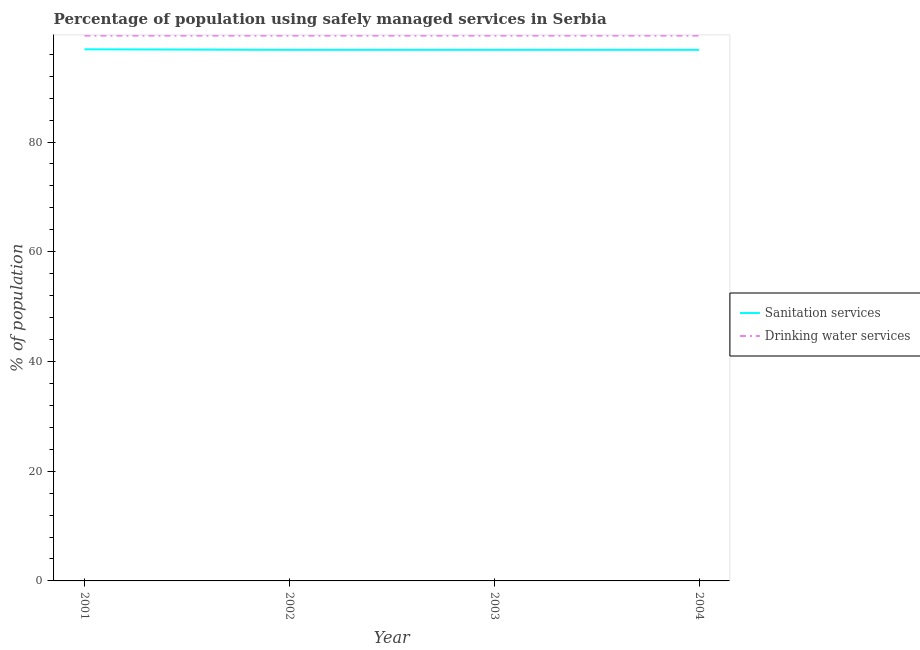How many different coloured lines are there?
Offer a very short reply. 2. Is the number of lines equal to the number of legend labels?
Give a very brief answer. Yes. What is the percentage of population who used sanitation services in 2004?
Your answer should be very brief. 96.8. Across all years, what is the maximum percentage of population who used drinking water services?
Provide a short and direct response. 99.4. Across all years, what is the minimum percentage of population who used drinking water services?
Make the answer very short. 99.4. In which year was the percentage of population who used drinking water services minimum?
Provide a succinct answer. 2001. What is the total percentage of population who used sanitation services in the graph?
Your answer should be compact. 387.3. What is the difference between the percentage of population who used sanitation services in 2003 and that in 2004?
Keep it short and to the point. 0. What is the average percentage of population who used sanitation services per year?
Keep it short and to the point. 96.83. In the year 2004, what is the difference between the percentage of population who used sanitation services and percentage of population who used drinking water services?
Your answer should be compact. -2.6. In how many years, is the percentage of population who used sanitation services greater than 84 %?
Offer a very short reply. 4. What is the ratio of the percentage of population who used drinking water services in 2001 to that in 2004?
Offer a terse response. 1. Is the percentage of population who used sanitation services in 2001 less than that in 2004?
Give a very brief answer. No. What is the difference between the highest and the second highest percentage of population who used sanitation services?
Provide a short and direct response. 0.1. What is the difference between the highest and the lowest percentage of population who used drinking water services?
Offer a very short reply. 0. In how many years, is the percentage of population who used sanitation services greater than the average percentage of population who used sanitation services taken over all years?
Offer a very short reply. 1. Is the sum of the percentage of population who used sanitation services in 2001 and 2003 greater than the maximum percentage of population who used drinking water services across all years?
Your answer should be very brief. Yes. Is the percentage of population who used drinking water services strictly less than the percentage of population who used sanitation services over the years?
Your answer should be very brief. No. How many lines are there?
Your response must be concise. 2. Does the graph contain any zero values?
Provide a succinct answer. No. Where does the legend appear in the graph?
Your answer should be compact. Center right. How many legend labels are there?
Provide a short and direct response. 2. What is the title of the graph?
Make the answer very short. Percentage of population using safely managed services in Serbia. Does "Forest land" appear as one of the legend labels in the graph?
Give a very brief answer. No. What is the label or title of the Y-axis?
Your response must be concise. % of population. What is the % of population in Sanitation services in 2001?
Provide a succinct answer. 96.9. What is the % of population of Drinking water services in 2001?
Give a very brief answer. 99.4. What is the % of population of Sanitation services in 2002?
Ensure brevity in your answer.  96.8. What is the % of population of Drinking water services in 2002?
Your answer should be compact. 99.4. What is the % of population of Sanitation services in 2003?
Offer a terse response. 96.8. What is the % of population of Drinking water services in 2003?
Offer a terse response. 99.4. What is the % of population of Sanitation services in 2004?
Offer a very short reply. 96.8. What is the % of population in Drinking water services in 2004?
Offer a terse response. 99.4. Across all years, what is the maximum % of population in Sanitation services?
Ensure brevity in your answer.  96.9. Across all years, what is the maximum % of population in Drinking water services?
Provide a succinct answer. 99.4. Across all years, what is the minimum % of population in Sanitation services?
Provide a succinct answer. 96.8. Across all years, what is the minimum % of population of Drinking water services?
Ensure brevity in your answer.  99.4. What is the total % of population in Sanitation services in the graph?
Provide a succinct answer. 387.3. What is the total % of population of Drinking water services in the graph?
Your response must be concise. 397.6. What is the difference between the % of population of Sanitation services in 2001 and that in 2002?
Make the answer very short. 0.1. What is the difference between the % of population of Drinking water services in 2001 and that in 2003?
Provide a short and direct response. 0. What is the difference between the % of population of Drinking water services in 2001 and that in 2004?
Give a very brief answer. 0. What is the difference between the % of population in Drinking water services in 2002 and that in 2003?
Offer a terse response. 0. What is the difference between the % of population of Sanitation services in 2002 and that in 2004?
Provide a succinct answer. 0. What is the difference between the % of population of Sanitation services in 2003 and that in 2004?
Provide a short and direct response. 0. What is the difference between the % of population in Sanitation services in 2001 and the % of population in Drinking water services in 2003?
Offer a very short reply. -2.5. What is the difference between the % of population of Sanitation services in 2002 and the % of population of Drinking water services in 2003?
Give a very brief answer. -2.6. What is the difference between the % of population of Sanitation services in 2003 and the % of population of Drinking water services in 2004?
Make the answer very short. -2.6. What is the average % of population of Sanitation services per year?
Your response must be concise. 96.83. What is the average % of population of Drinking water services per year?
Provide a succinct answer. 99.4. In the year 2003, what is the difference between the % of population in Sanitation services and % of population in Drinking water services?
Give a very brief answer. -2.6. What is the ratio of the % of population in Drinking water services in 2001 to that in 2002?
Give a very brief answer. 1. What is the ratio of the % of population of Sanitation services in 2001 to that in 2003?
Make the answer very short. 1. What is the ratio of the % of population in Drinking water services in 2001 to that in 2003?
Ensure brevity in your answer.  1. What is the ratio of the % of population of Sanitation services in 2001 to that in 2004?
Your answer should be compact. 1. What is the ratio of the % of population of Drinking water services in 2001 to that in 2004?
Offer a terse response. 1. What is the ratio of the % of population in Drinking water services in 2002 to that in 2003?
Your response must be concise. 1. What is the ratio of the % of population in Sanitation services in 2003 to that in 2004?
Keep it short and to the point. 1. What is the difference between the highest and the second highest % of population of Drinking water services?
Keep it short and to the point. 0. What is the difference between the highest and the lowest % of population in Sanitation services?
Give a very brief answer. 0.1. 